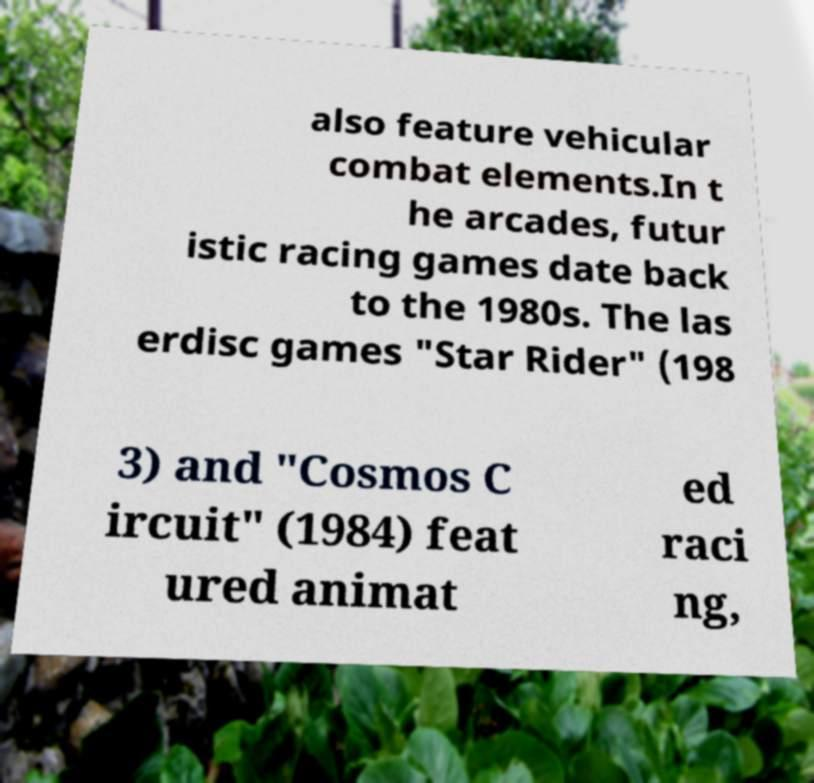What messages or text are displayed in this image? I need them in a readable, typed format. also feature vehicular combat elements.In t he arcades, futur istic racing games date back to the 1980s. The las erdisc games "Star Rider" (198 3) and "Cosmos C ircuit" (1984) feat ured animat ed raci ng, 